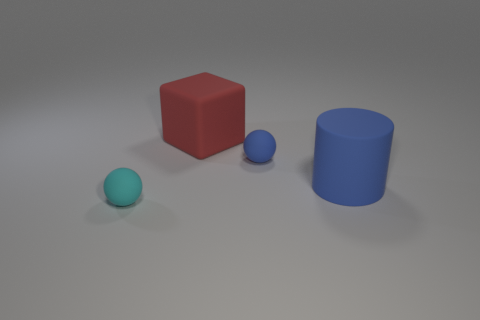What number of spheres are there?
Offer a terse response. 2. Is there anything else that has the same shape as the red thing?
Give a very brief answer. No. What is the blue sphere made of?
Offer a very short reply. Rubber. How many small balls have the same material as the large blue cylinder?
Give a very brief answer. 2. What number of rubber things are either big blue things or blue objects?
Make the answer very short. 2. Do the small matte object to the left of the large red object and the small rubber thing that is behind the cylinder have the same shape?
Offer a terse response. Yes. There is a rubber thing that is on the left side of the blue rubber sphere and in front of the red matte object; what is its color?
Give a very brief answer. Cyan. Do the matte sphere that is in front of the big matte cylinder and the blue thing left of the matte cylinder have the same size?
Give a very brief answer. Yes. What number of tiny matte objects are the same color as the large cylinder?
Give a very brief answer. 1. How many small objects are green metal blocks or matte balls?
Offer a very short reply. 2. 